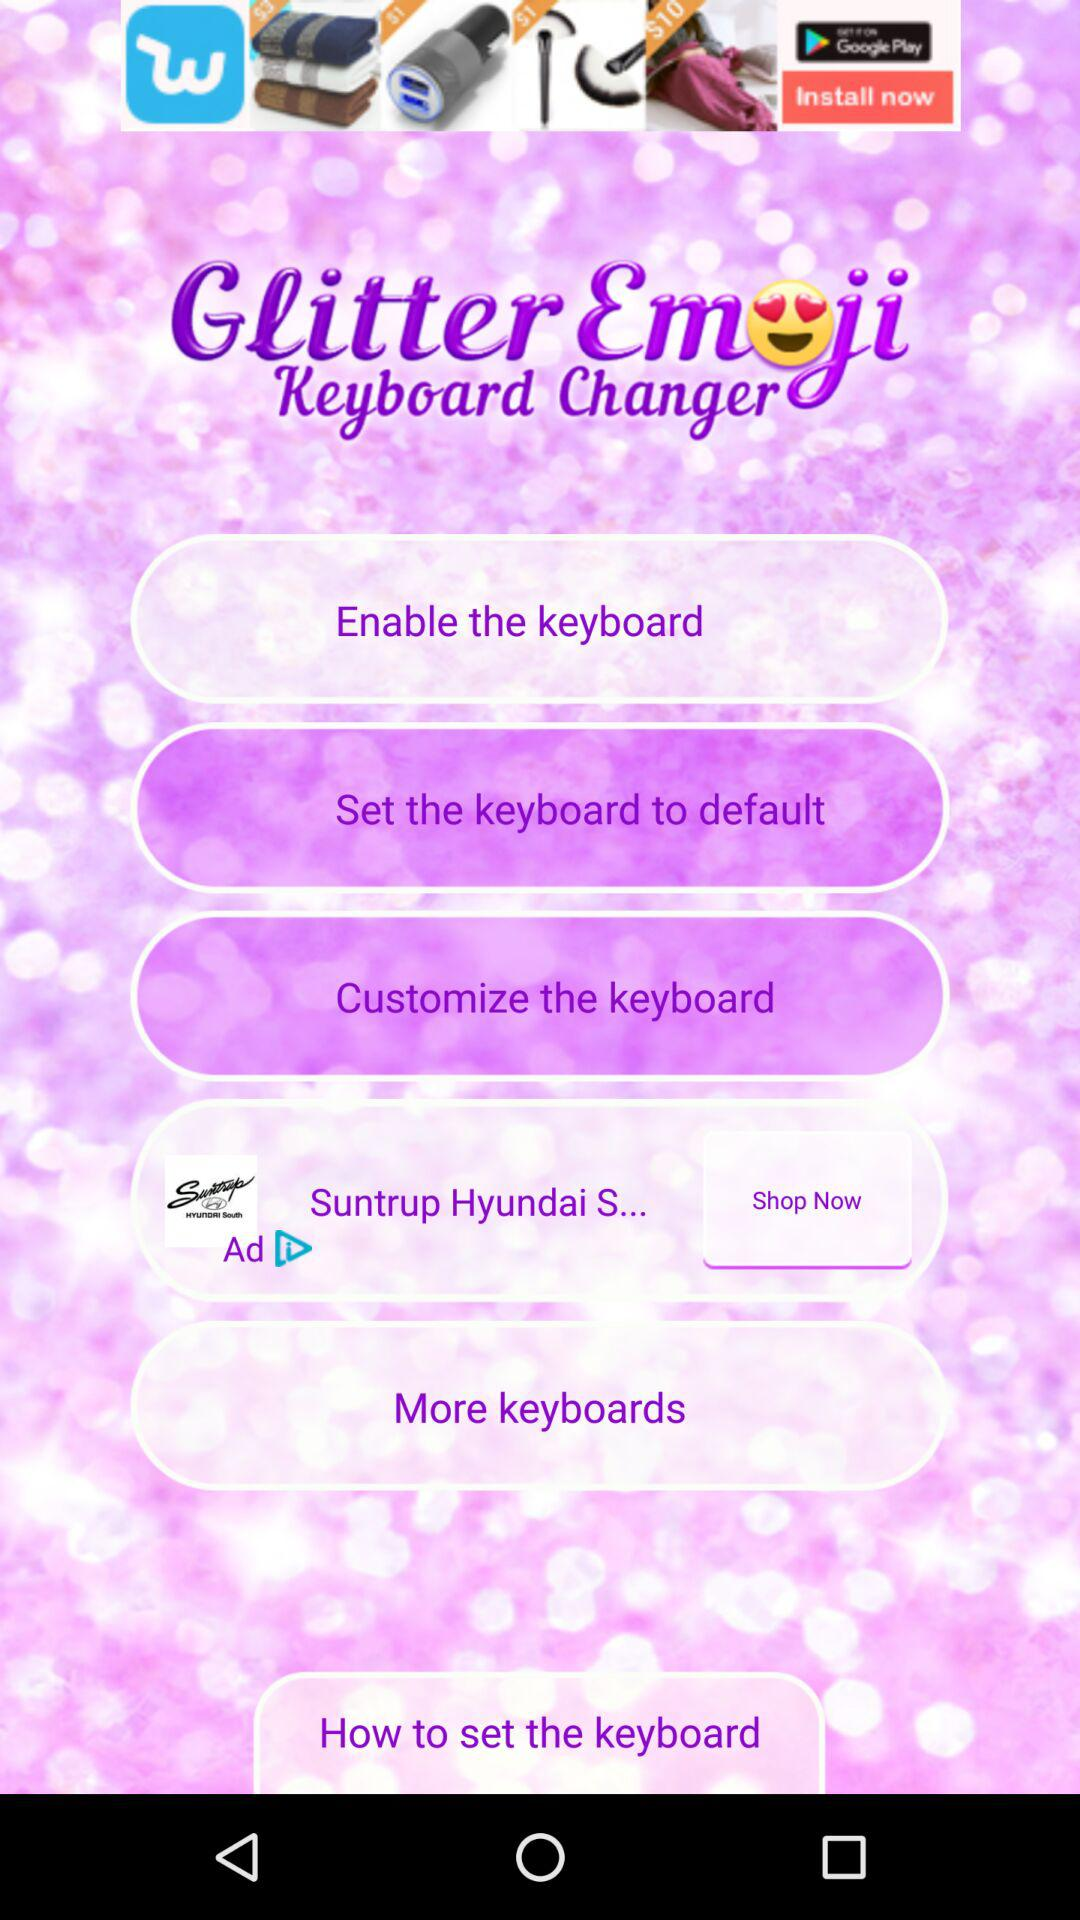What is the app name? The app name is "Glitter Emoji Keyboard Changer". 